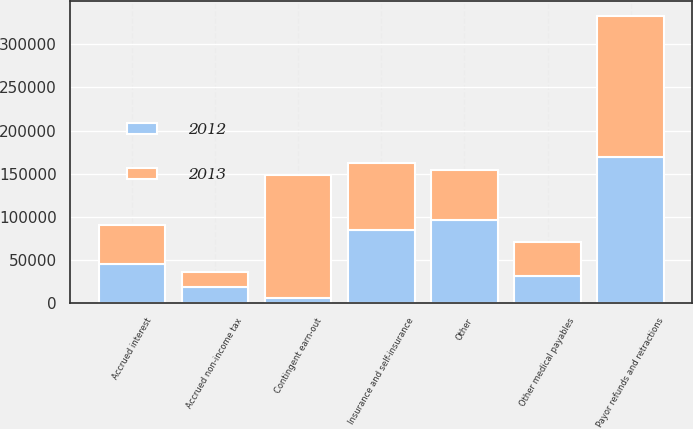Convert chart to OTSL. <chart><loc_0><loc_0><loc_500><loc_500><stacked_bar_chart><ecel><fcel>Payor refunds and retractions<fcel>Contingent earn-out<fcel>Insurance and self-insurance<fcel>Accrued interest<fcel>Other medical payables<fcel>Accrued non-income tax<fcel>Other<nl><fcel>2012<fcel>169480<fcel>6577<fcel>84882<fcel>45662<fcel>31219<fcel>18366<fcel>96167<nl><fcel>2013<fcel>163520<fcel>142244<fcel>78073<fcel>44884<fcel>39698<fcel>17976<fcel>58530<nl></chart> 